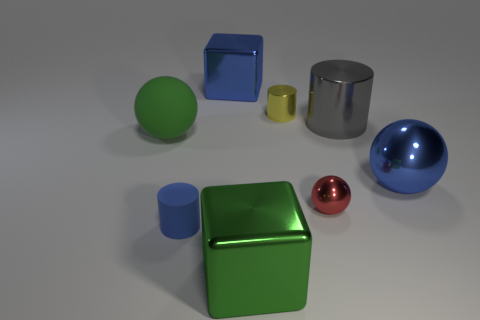What is the texture of the surfaces the objects are on? The surface on which the objects are resting looks smooth and matte, lacking any pronounced texture that might interfere with the reflection of the objects. 